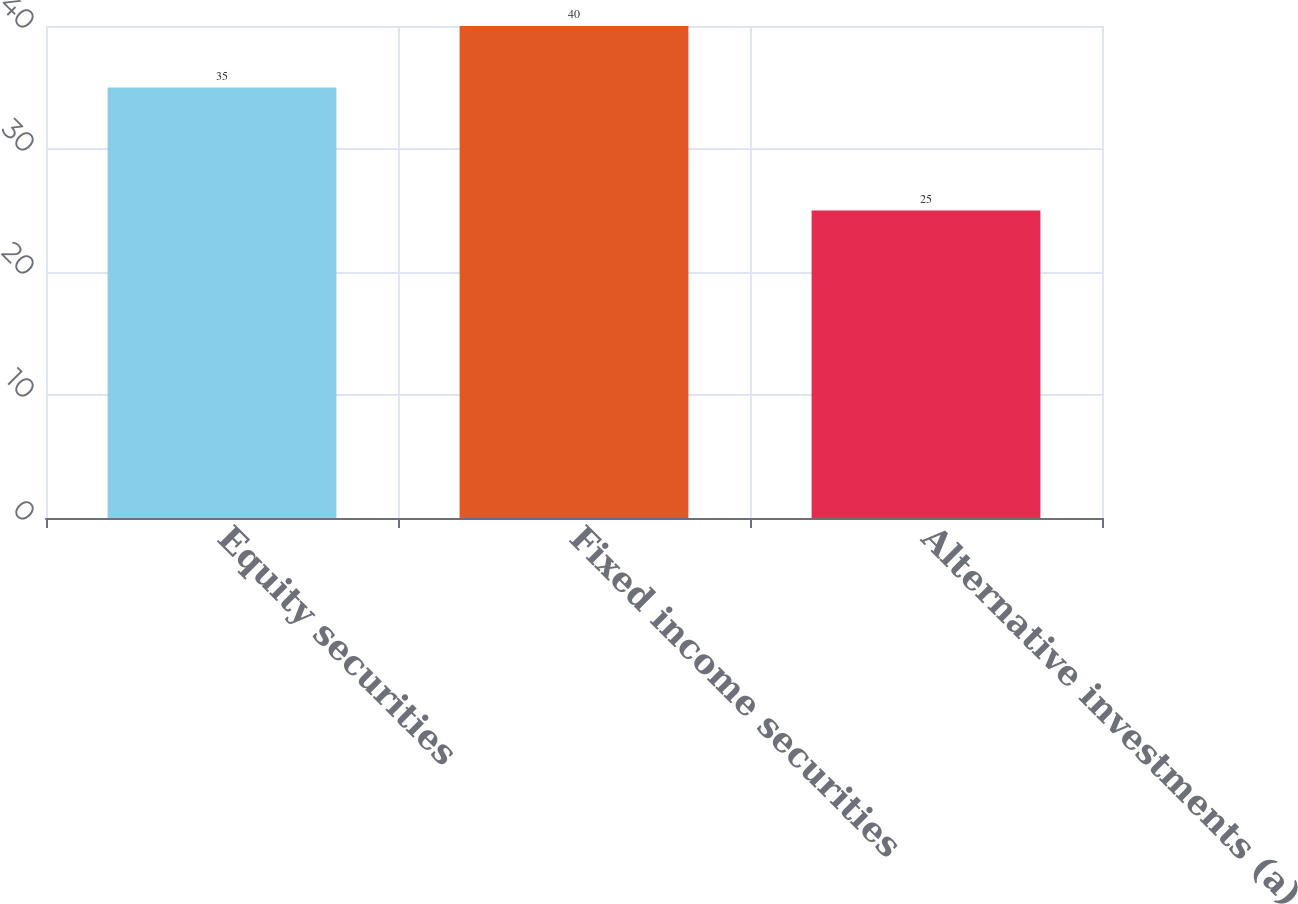Convert chart to OTSL. <chart><loc_0><loc_0><loc_500><loc_500><bar_chart><fcel>Equity securities<fcel>Fixed income securities<fcel>Alternative investments (a)<nl><fcel>35<fcel>40<fcel>25<nl></chart> 